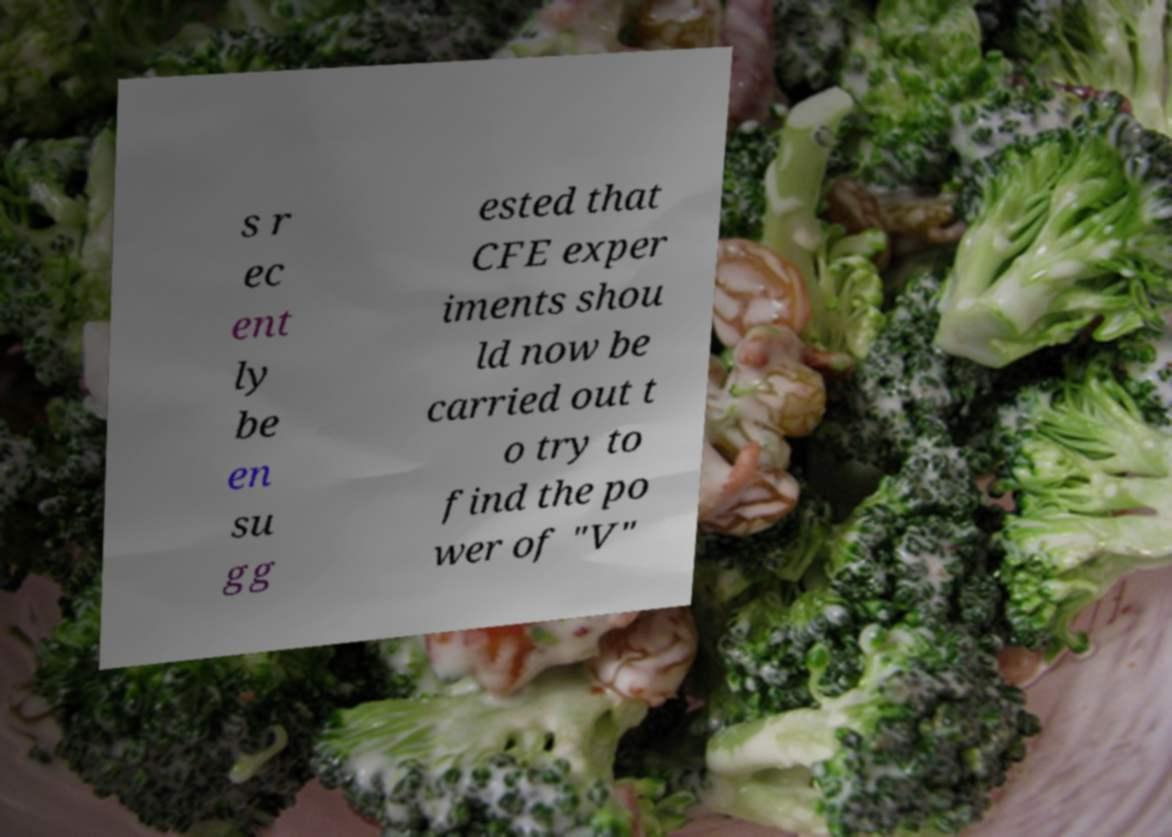I need the written content from this picture converted into text. Can you do that? s r ec ent ly be en su gg ested that CFE exper iments shou ld now be carried out t o try to find the po wer of "V" 